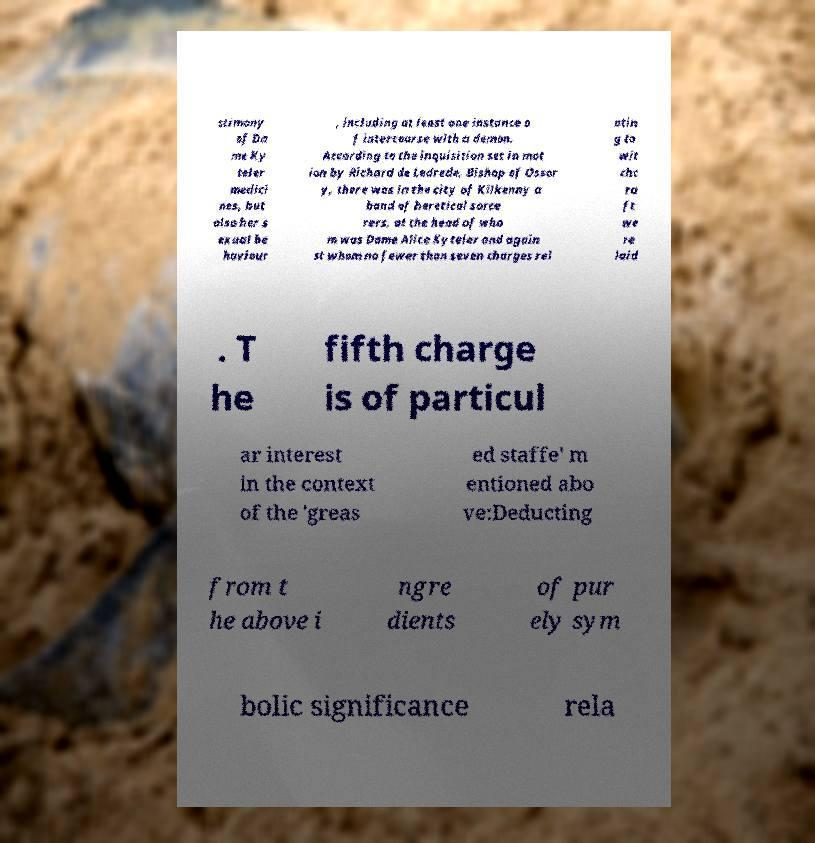Please identify and transcribe the text found in this image. stimony of Da me Ky teler medici nes, but also her s exual be haviour , including at least one instance o f intercourse with a demon. According to the inquisition set in mot ion by Richard de Ledrede, Bishop of Ossor y, there was in the city of Kilkenny a band of heretical sorce rers, at the head of who m was Dame Alice Kyteler and again st whom no fewer than seven charges rel atin g to wit chc ra ft we re laid . T he fifth charge is of particul ar interest in the context of the 'greas ed staffe' m entioned abo ve:Deducting from t he above i ngre dients of pur ely sym bolic significance rela 